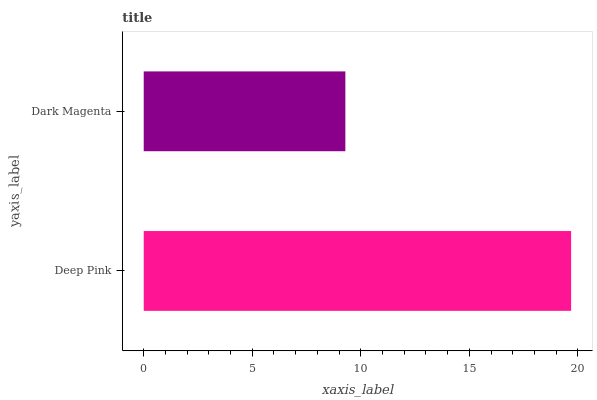Is Dark Magenta the minimum?
Answer yes or no. Yes. Is Deep Pink the maximum?
Answer yes or no. Yes. Is Dark Magenta the maximum?
Answer yes or no. No. Is Deep Pink greater than Dark Magenta?
Answer yes or no. Yes. Is Dark Magenta less than Deep Pink?
Answer yes or no. Yes. Is Dark Magenta greater than Deep Pink?
Answer yes or no. No. Is Deep Pink less than Dark Magenta?
Answer yes or no. No. Is Deep Pink the high median?
Answer yes or no. Yes. Is Dark Magenta the low median?
Answer yes or no. Yes. Is Dark Magenta the high median?
Answer yes or no. No. Is Deep Pink the low median?
Answer yes or no. No. 